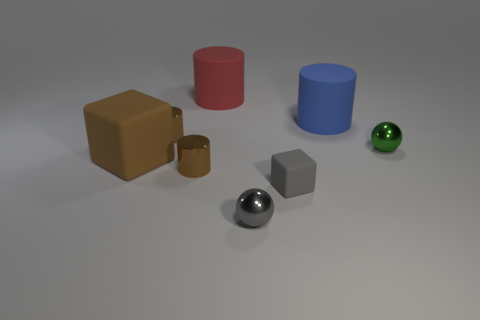Can you tell me which objects in the image are spheres? Certainly, there are two spheres in the image. One is green and located on the right side, while the other appears to be a shiny silver sphere located near the center. 